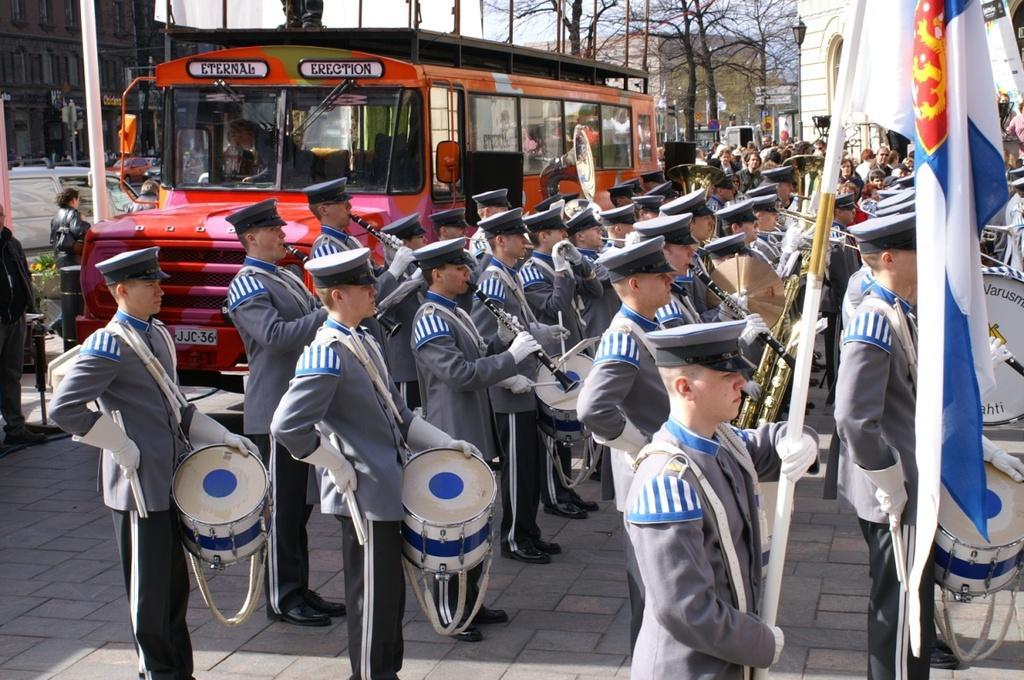Could you give a brief overview of what you see in this image? In this picture we can see few people are standing and playing musical instruments, among one person is holding flag, behind we can see few vehicles, buildings and some trees. 